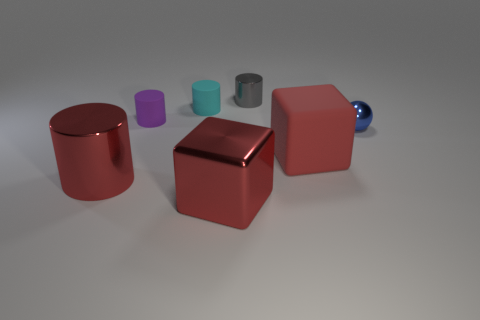Subtract all yellow cylinders. Subtract all brown balls. How many cylinders are left? 4 Add 3 tiny gray metal blocks. How many objects exist? 10 Subtract all balls. How many objects are left? 6 Add 5 cyan rubber blocks. How many cyan rubber blocks exist? 5 Subtract 1 blue balls. How many objects are left? 6 Subtract all brown rubber cylinders. Subtract all small cyan matte objects. How many objects are left? 6 Add 3 cylinders. How many cylinders are left? 7 